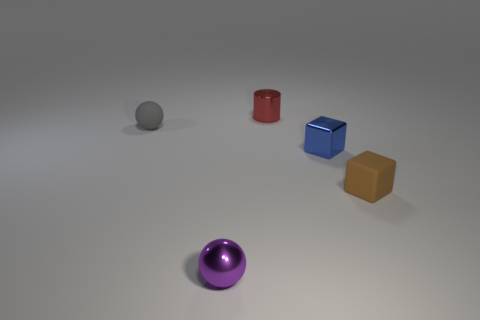Subtract 1 blocks. How many blocks are left? 1 Add 5 small purple shiny balls. How many small purple shiny balls are left? 6 Add 1 big purple blocks. How many big purple blocks exist? 1 Add 1 large blue cylinders. How many objects exist? 6 Subtract 0 brown cylinders. How many objects are left? 5 Subtract all cubes. How many objects are left? 3 Subtract all gray cylinders. Subtract all green spheres. How many cylinders are left? 1 Subtract all blue blocks. How many red balls are left? 0 Subtract all red cubes. Subtract all cylinders. How many objects are left? 4 